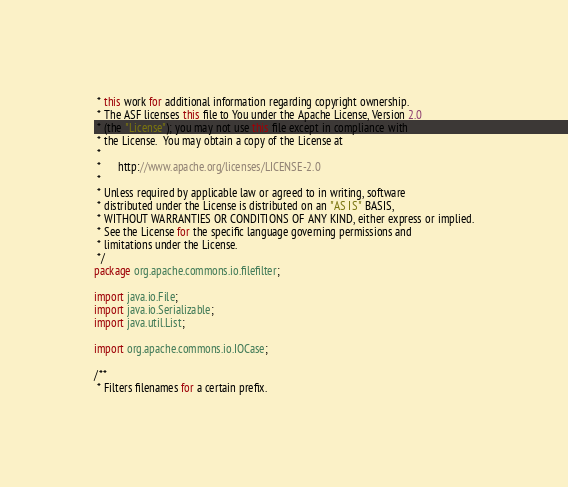<code> <loc_0><loc_0><loc_500><loc_500><_Java_> * this work for additional information regarding copyright ownership.
 * The ASF licenses this file to You under the Apache License, Version 2.0
 * (the "License"); you may not use this file except in compliance with
 * the License.  You may obtain a copy of the License at
 * 
 *      http://www.apache.org/licenses/LICENSE-2.0
 * 
 * Unless required by applicable law or agreed to in writing, software
 * distributed under the License is distributed on an "AS IS" BASIS,
 * WITHOUT WARRANTIES OR CONDITIONS OF ANY KIND, either express or implied.
 * See the License for the specific language governing permissions and
 * limitations under the License.
 */
package org.apache.commons.io.filefilter;

import java.io.File;
import java.io.Serializable;
import java.util.List;

import org.apache.commons.io.IOCase;

/**
 * Filters filenames for a certain prefix.</code> 